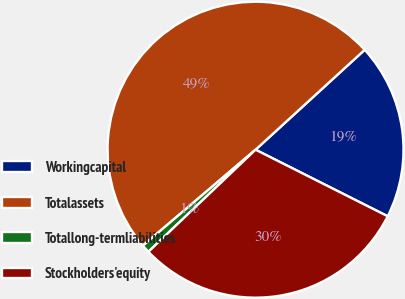Convert chart to OTSL. <chart><loc_0><loc_0><loc_500><loc_500><pie_chart><fcel>Workingcapital<fcel>Totalassets<fcel>Totallong-termliabilities<fcel>Stockholders'equity<nl><fcel>19.22%<fcel>49.43%<fcel>0.89%<fcel>30.46%<nl></chart> 